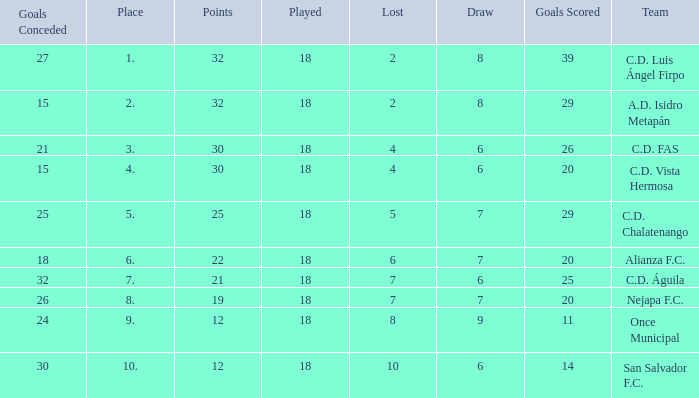What is the sum of draw with a lost smaller than 6, and a place of 5, and a goals scored less than 29? None. 